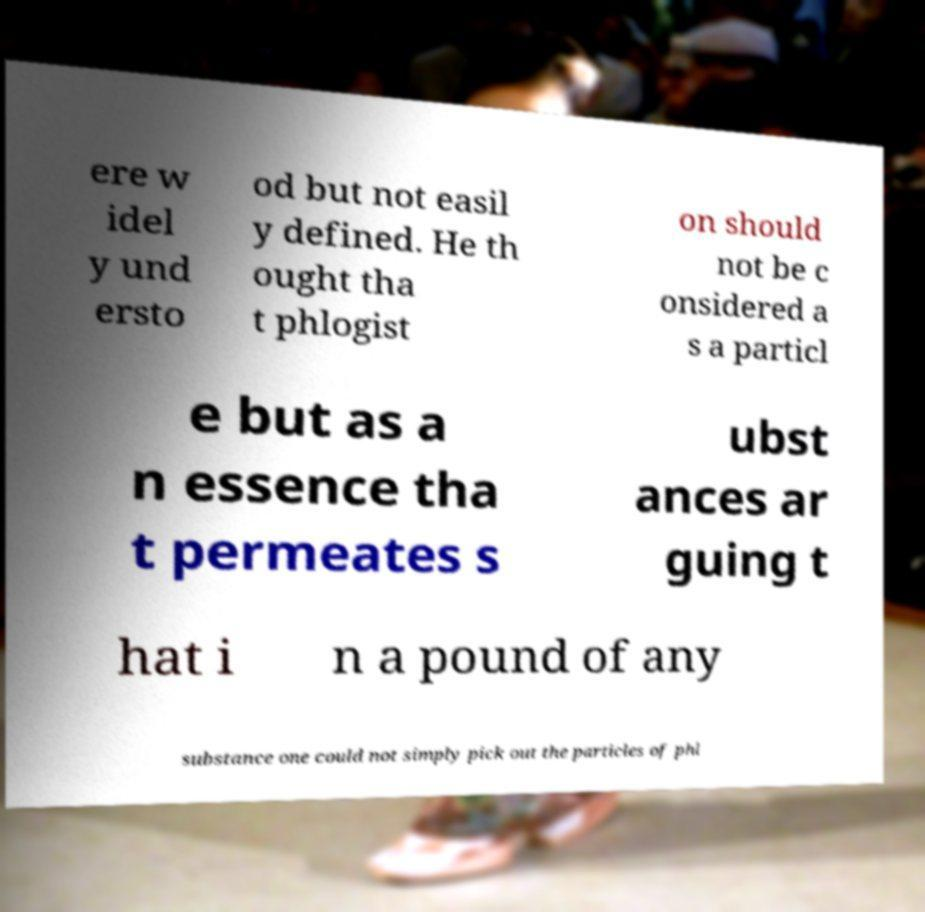I need the written content from this picture converted into text. Can you do that? ere w idel y und ersto od but not easil y defined. He th ought tha t phlogist on should not be c onsidered a s a particl e but as a n essence tha t permeates s ubst ances ar guing t hat i n a pound of any substance one could not simply pick out the particles of phl 